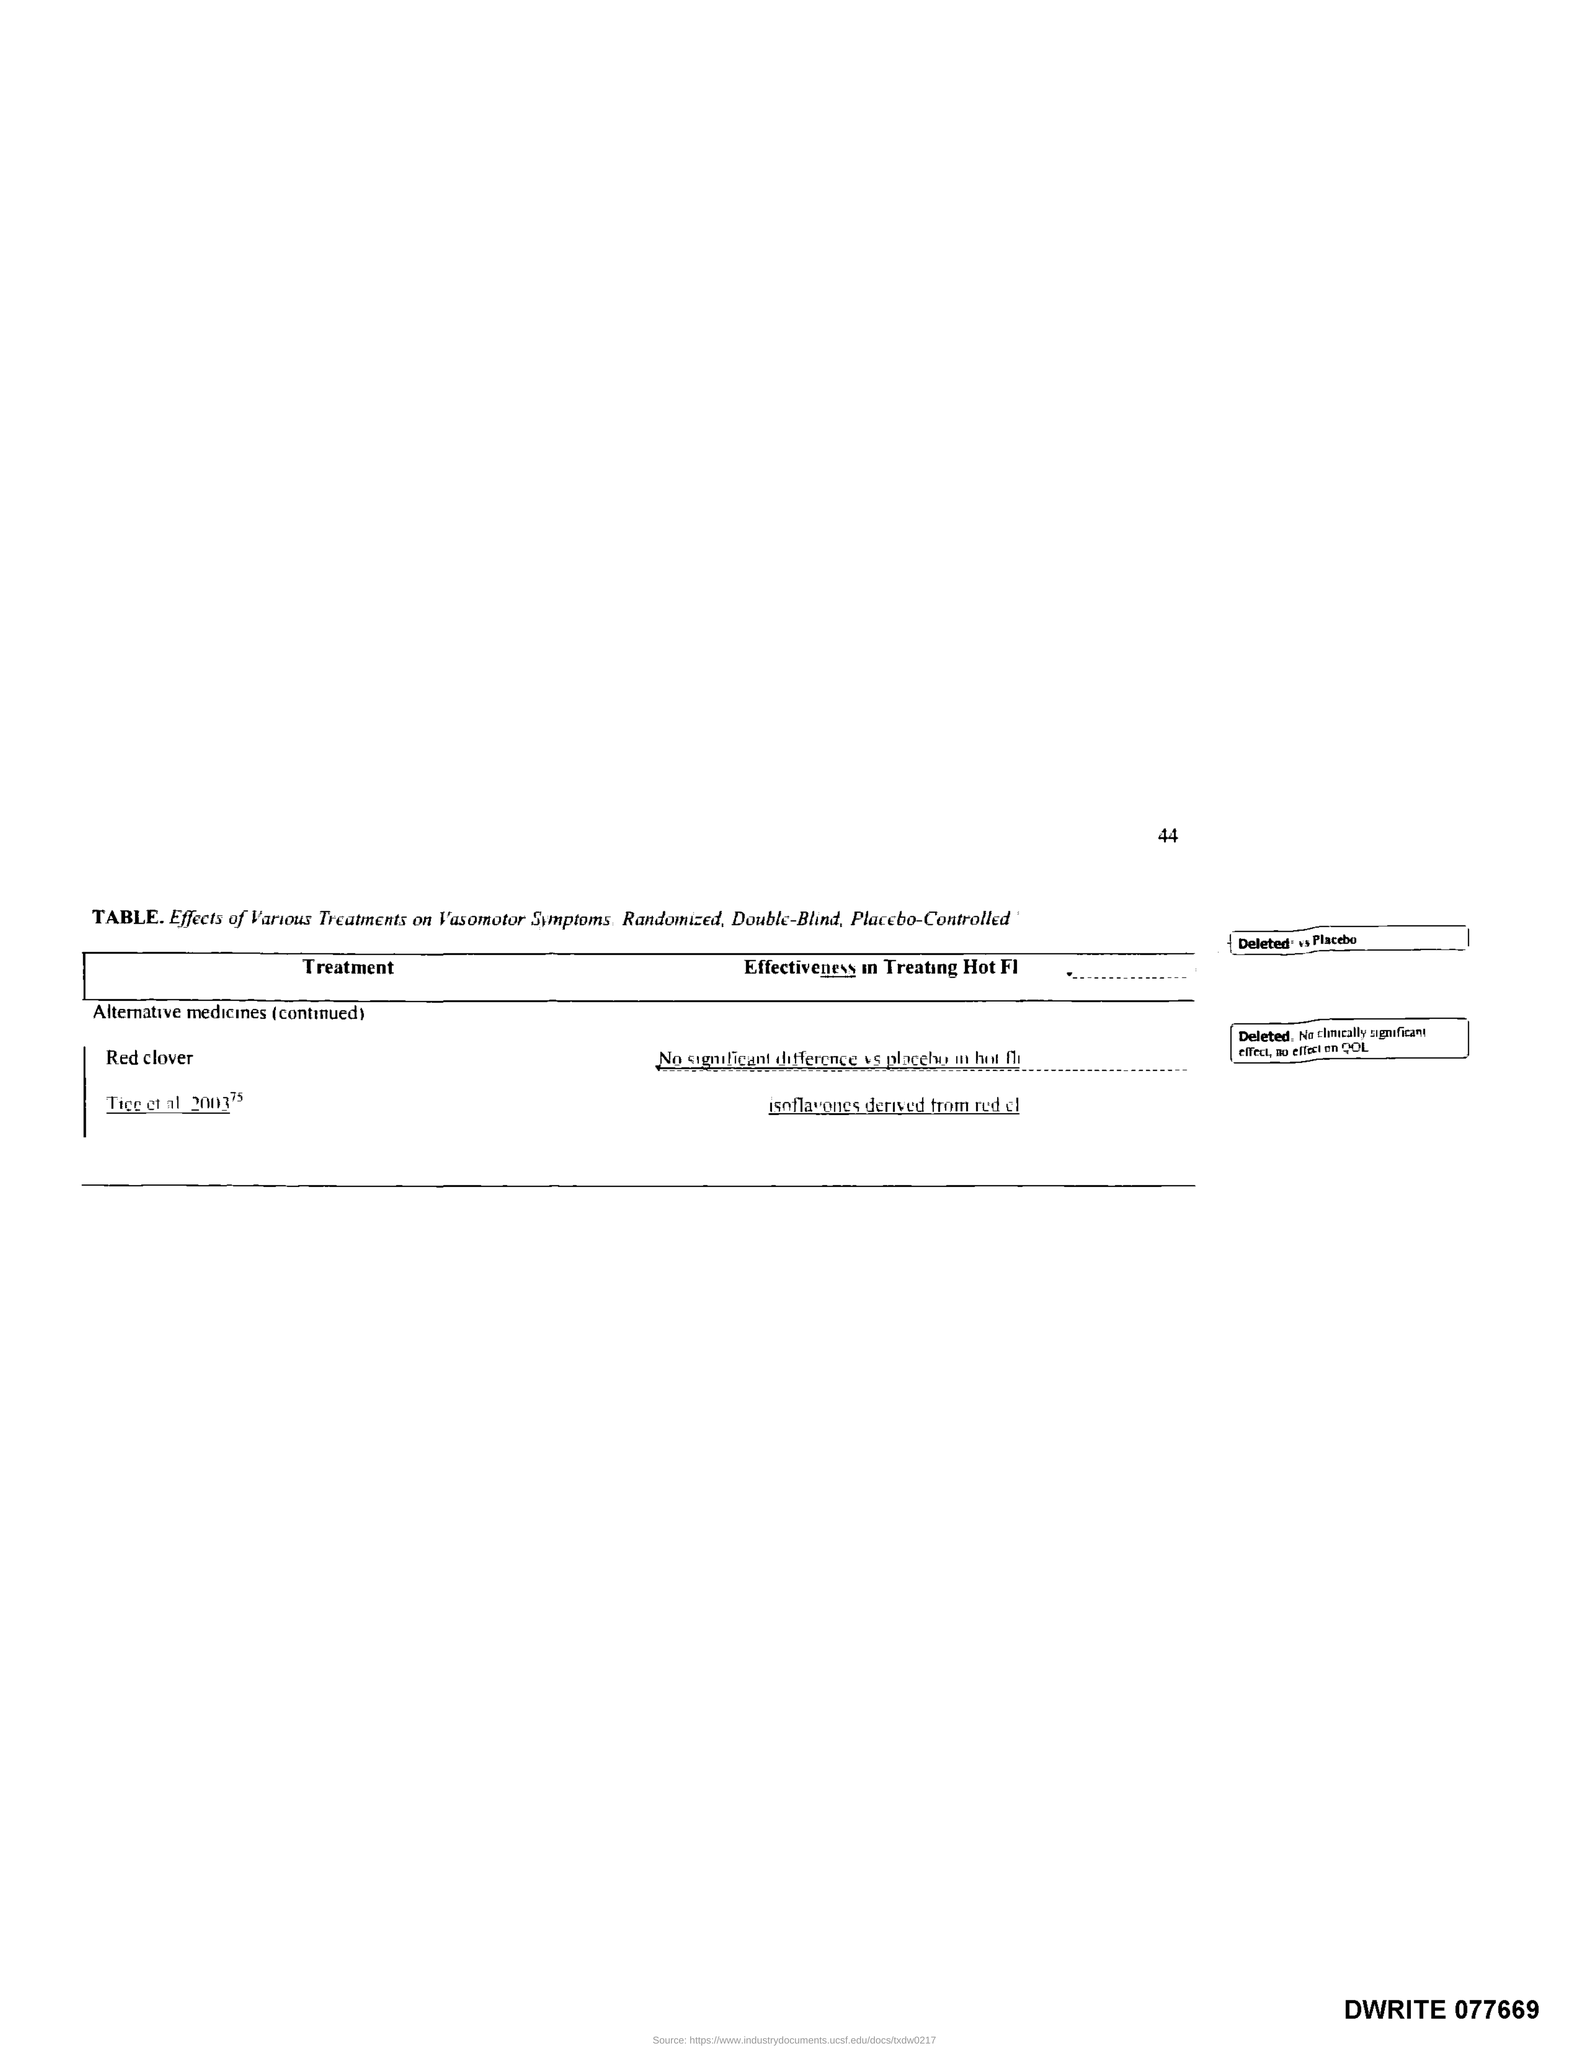Point out several critical features in this image. The page number is 44. The title of the first column of the table is 'Treatment'. 